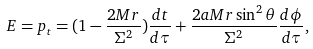<formula> <loc_0><loc_0><loc_500><loc_500>E = p _ { t } = ( 1 - \frac { 2 M r } { \Sigma ^ { 2 } } ) \frac { d t } { d \tau } + \frac { 2 a M r \sin ^ { 2 } \theta } { \Sigma ^ { 2 } } \frac { d \phi } { d \tau } ,</formula> 